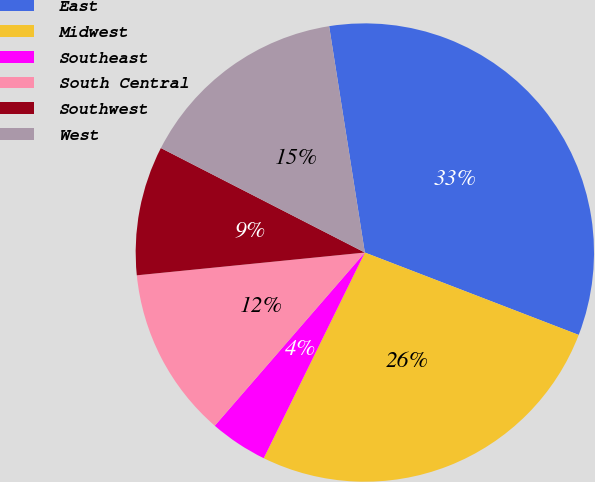Convert chart to OTSL. <chart><loc_0><loc_0><loc_500><loc_500><pie_chart><fcel>East<fcel>Midwest<fcel>Southeast<fcel>South Central<fcel>Southwest<fcel>West<nl><fcel>33.34%<fcel>26.42%<fcel>4.09%<fcel>12.05%<fcel>9.12%<fcel>14.97%<nl></chart> 